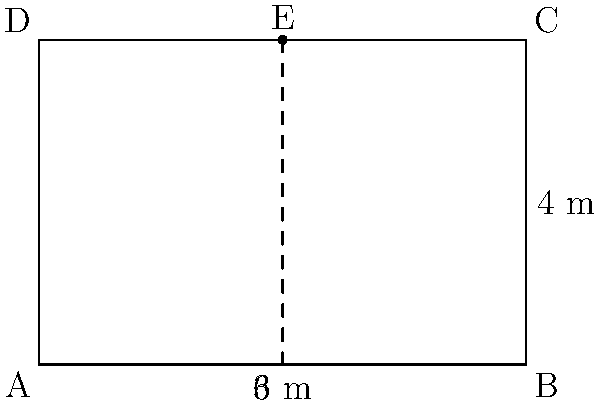During a geological tour of Ngorongoro Crater in Tanzania, you come across a nearly rectangular cross-section of a smaller volcanic crater. The base of the cross-section measures 6 meters, and the height is 4 meters. If a vertical line is drawn from the midpoint of the top edge to the base, dividing the rectangle into two equal parts, what is the area of one of these parts in square meters? Let's approach this step-by-step:

1) First, we need to identify the shape we're working with. The cross-section is a rectangle, and we're asked to find the area of half of this rectangle.

2) The dimensions of the rectangle are:
   - Width: 6 meters
   - Height: 4 meters

3) To find the area of half the rectangle, we can:
   a) Calculate the total area and divide by 2, or
   b) Calculate the area of half the width and the full height

4) Let's use method b:
   - Half the width is: $6 \div 2 = 3$ meters
   - The height remains 4 meters

5) The area of a rectangle is given by the formula: $A = length \times width$

6) So, the area of half the rectangle is:
   $A = 3 \times 4 = 12$ square meters

Therefore, the area of one part of the divided rectangular cross-section is 12 square meters.
Answer: 12 m² 